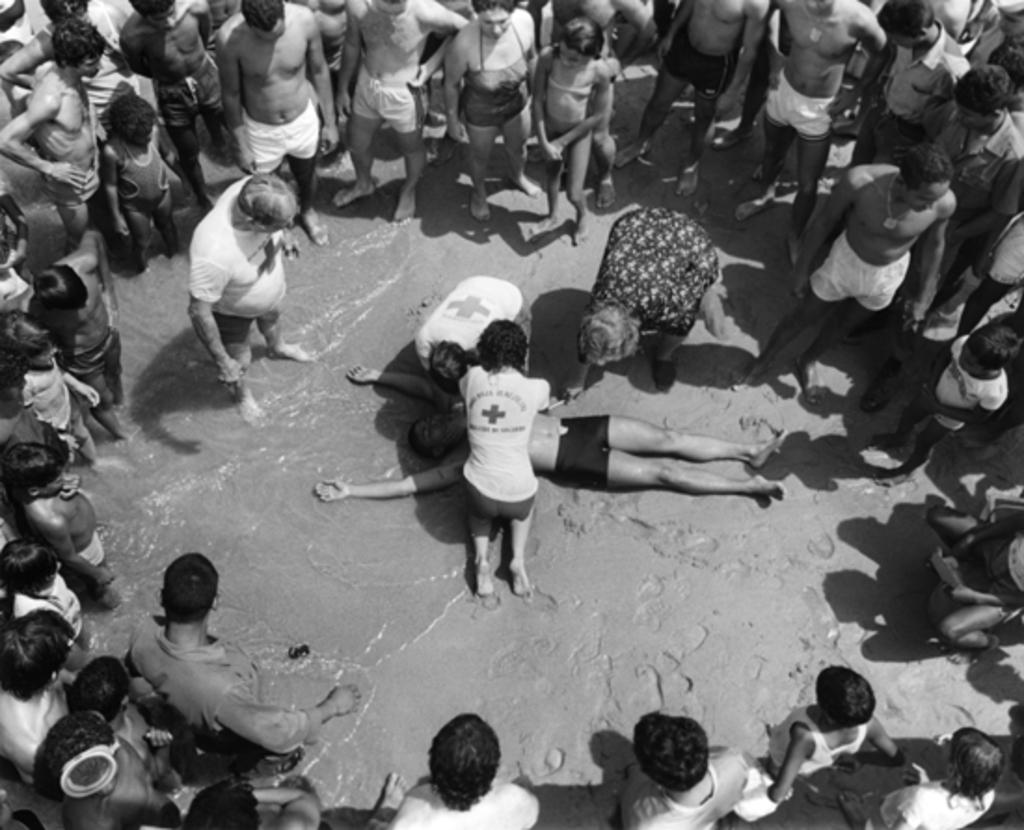What is the color scheme of the image? The image is black and white. Can you describe the people in the image? There are people in the image, but their specific actions or appearances are not mentioned in the facts. What is the position of one of the people in the image? There is a person lying on the ground in the image. What natural element is visible in the image? There is water visible in the image. What type of scent can be detected from the zebra in the image? There is no zebra present in the image, so it is not possible to detect any scent from it. 